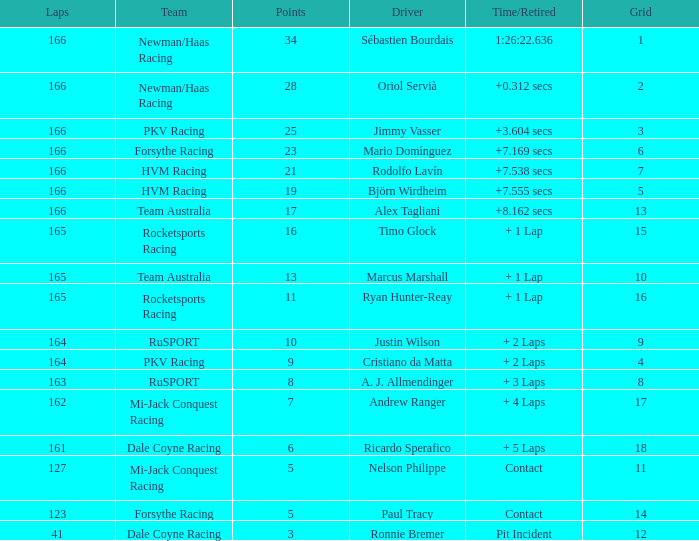What is the average points that the driver Ryan Hunter-Reay has? 11.0. 